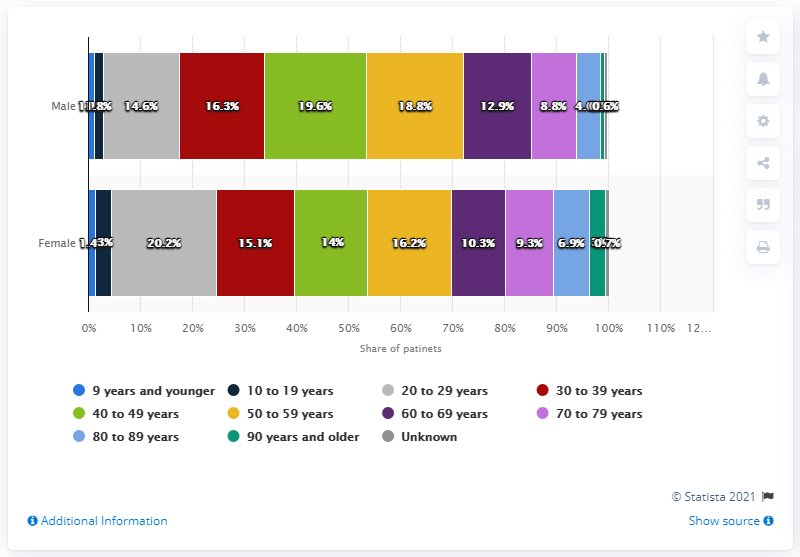Point out several critical features in this image. The COVID-19 patients represented a significant portion of the overall patient population, with women aged 20 to 29 years old comprising 20.2% of all patients. 